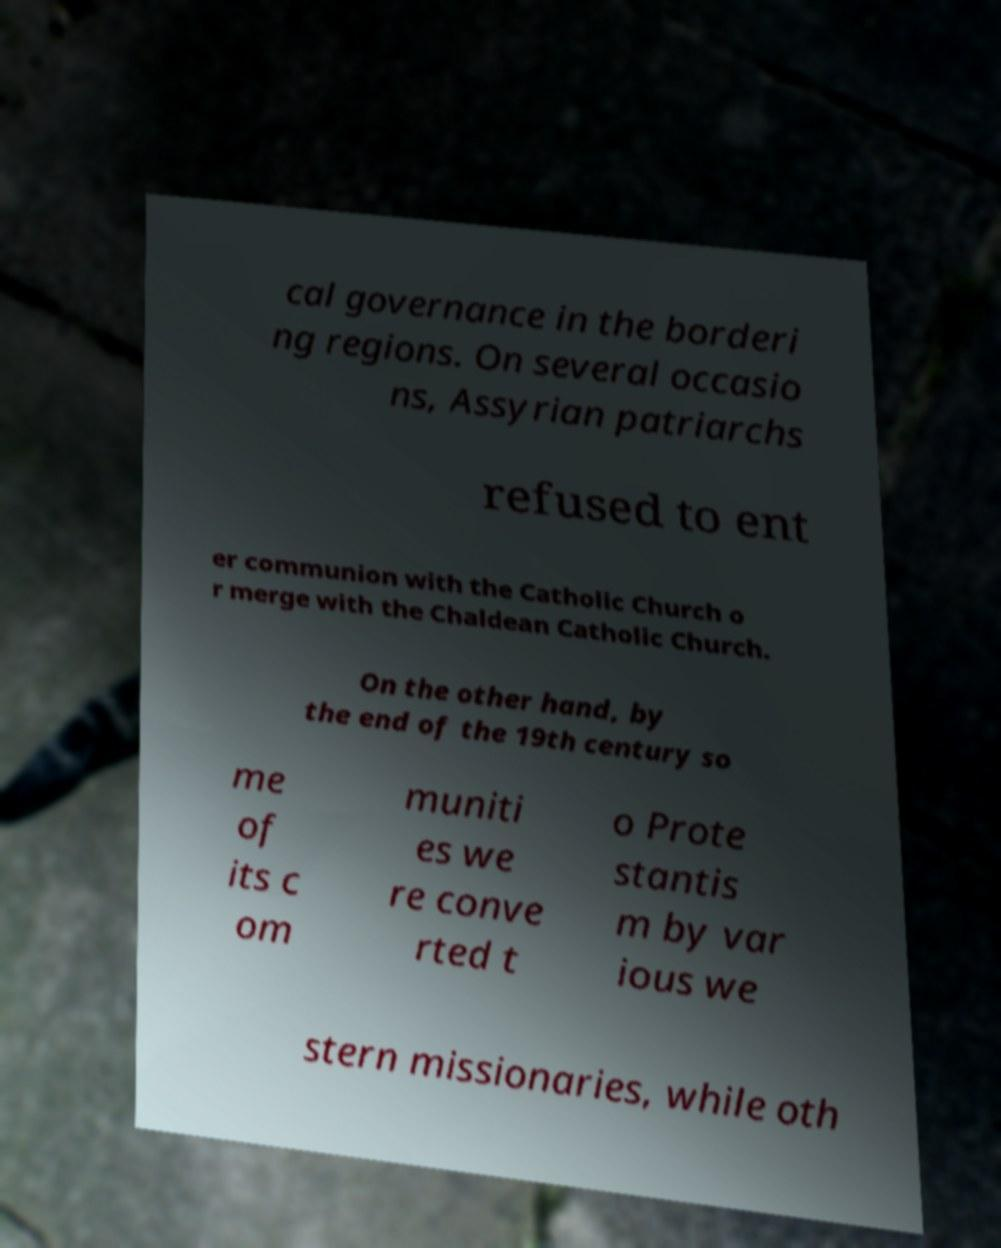Please identify and transcribe the text found in this image. cal governance in the borderi ng regions. On several occasio ns, Assyrian patriarchs refused to ent er communion with the Catholic Church o r merge with the Chaldean Catholic Church. On the other hand, by the end of the 19th century so me of its c om muniti es we re conve rted t o Prote stantis m by var ious we stern missionaries, while oth 